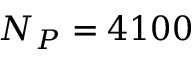<formula> <loc_0><loc_0><loc_500><loc_500>N _ { P } = 4 1 0 0</formula> 